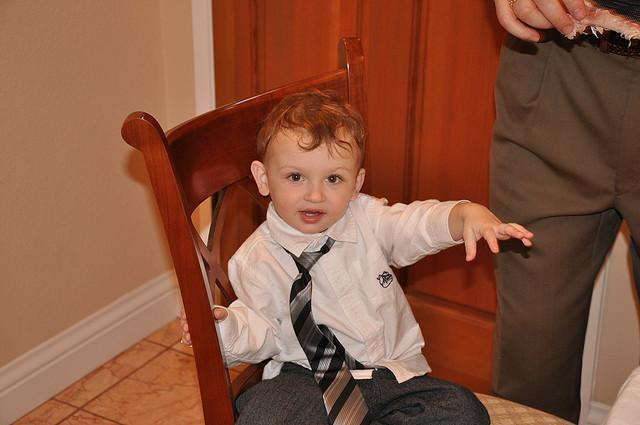What piece of clothing does the boy have on that are meant for adults?

Choices:
A) belt
B) tie
C) his shirt
D) pants tie 